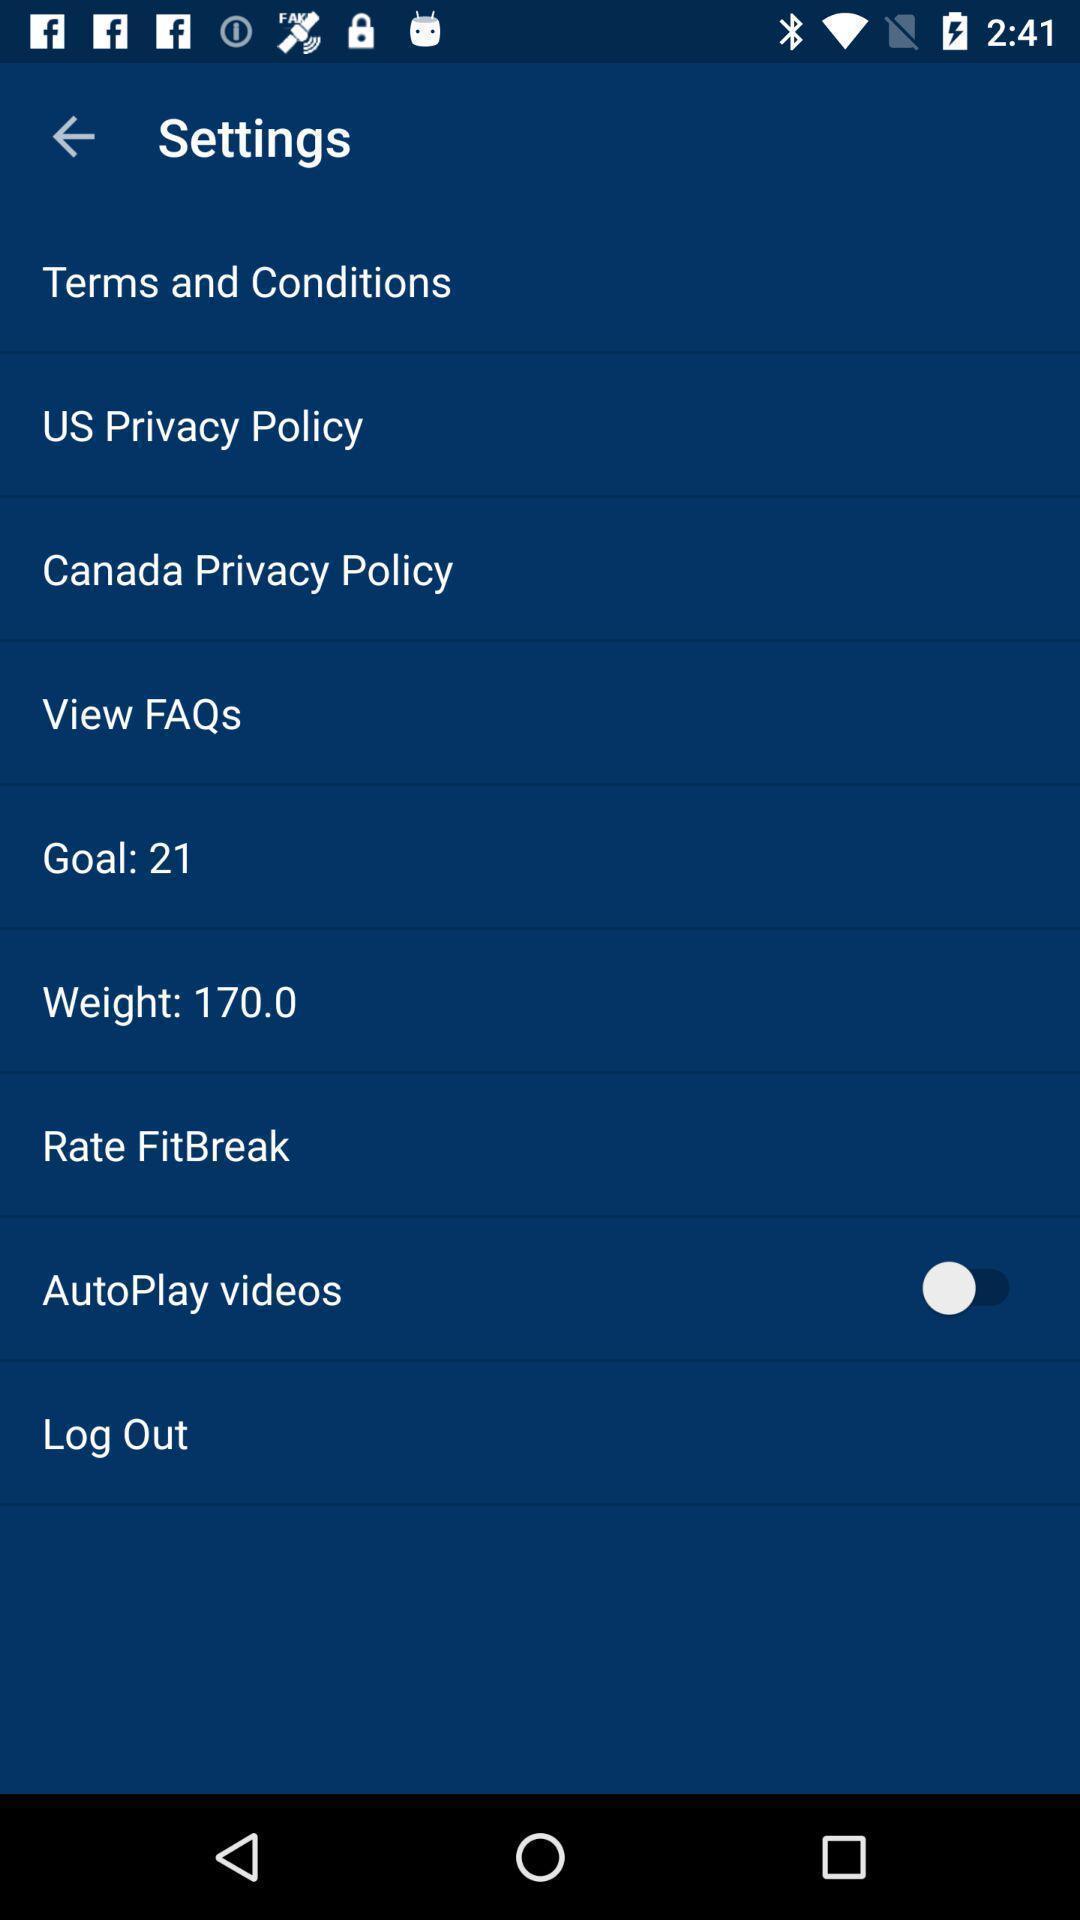Give me a summary of this screen capture. Screen displaying the settings. 